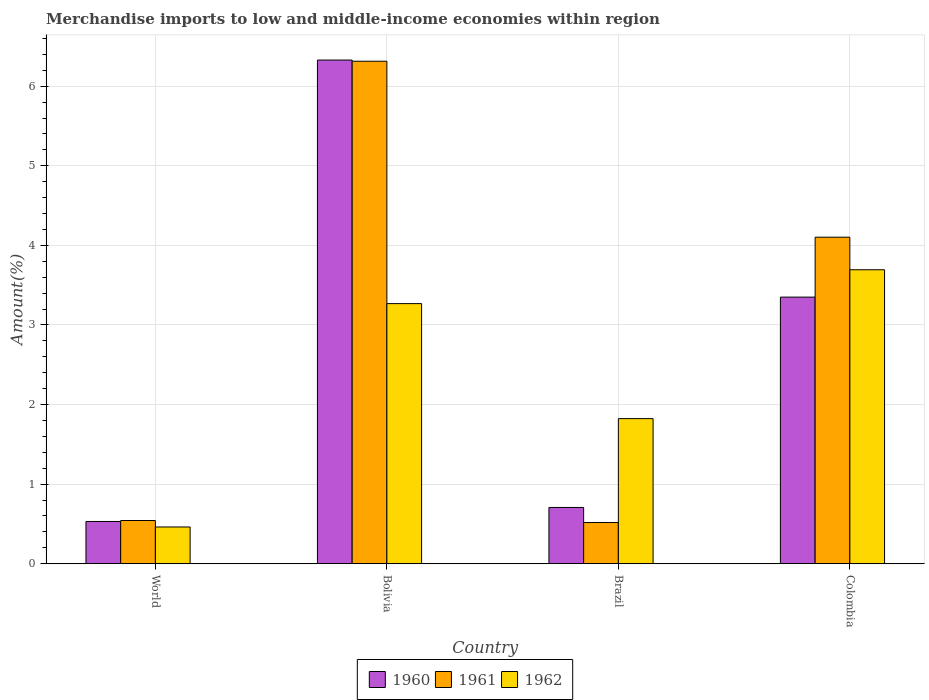How many groups of bars are there?
Keep it short and to the point. 4. Are the number of bars per tick equal to the number of legend labels?
Make the answer very short. Yes. Are the number of bars on each tick of the X-axis equal?
Provide a short and direct response. Yes. How many bars are there on the 2nd tick from the right?
Offer a very short reply. 3. In how many cases, is the number of bars for a given country not equal to the number of legend labels?
Offer a very short reply. 0. What is the percentage of amount earned from merchandise imports in 1962 in Bolivia?
Your response must be concise. 3.27. Across all countries, what is the maximum percentage of amount earned from merchandise imports in 1961?
Give a very brief answer. 6.31. Across all countries, what is the minimum percentage of amount earned from merchandise imports in 1962?
Give a very brief answer. 0.46. In which country was the percentage of amount earned from merchandise imports in 1961 maximum?
Your response must be concise. Bolivia. What is the total percentage of amount earned from merchandise imports in 1961 in the graph?
Keep it short and to the point. 11.48. What is the difference between the percentage of amount earned from merchandise imports in 1962 in Colombia and that in World?
Your answer should be compact. 3.23. What is the difference between the percentage of amount earned from merchandise imports in 1960 in Brazil and the percentage of amount earned from merchandise imports in 1962 in Bolivia?
Make the answer very short. -2.56. What is the average percentage of amount earned from merchandise imports in 1962 per country?
Provide a short and direct response. 2.31. What is the difference between the percentage of amount earned from merchandise imports of/in 1962 and percentage of amount earned from merchandise imports of/in 1960 in Brazil?
Offer a very short reply. 1.12. In how many countries, is the percentage of amount earned from merchandise imports in 1960 greater than 0.4 %?
Keep it short and to the point. 4. What is the ratio of the percentage of amount earned from merchandise imports in 1962 in Bolivia to that in Colombia?
Your response must be concise. 0.88. Is the percentage of amount earned from merchandise imports in 1962 in Bolivia less than that in World?
Make the answer very short. No. Is the difference between the percentage of amount earned from merchandise imports in 1962 in Bolivia and Colombia greater than the difference between the percentage of amount earned from merchandise imports in 1960 in Bolivia and Colombia?
Your answer should be compact. No. What is the difference between the highest and the second highest percentage of amount earned from merchandise imports in 1960?
Your answer should be very brief. -2.64. What is the difference between the highest and the lowest percentage of amount earned from merchandise imports in 1961?
Ensure brevity in your answer.  5.8. In how many countries, is the percentage of amount earned from merchandise imports in 1960 greater than the average percentage of amount earned from merchandise imports in 1960 taken over all countries?
Keep it short and to the point. 2. Is the sum of the percentage of amount earned from merchandise imports in 1960 in Bolivia and World greater than the maximum percentage of amount earned from merchandise imports in 1962 across all countries?
Your answer should be compact. Yes. What does the 1st bar from the right in Bolivia represents?
Your answer should be compact. 1962. What is the difference between two consecutive major ticks on the Y-axis?
Give a very brief answer. 1. Does the graph contain any zero values?
Offer a terse response. No. Does the graph contain grids?
Provide a succinct answer. Yes. Where does the legend appear in the graph?
Offer a terse response. Bottom center. How are the legend labels stacked?
Provide a short and direct response. Horizontal. What is the title of the graph?
Your answer should be very brief. Merchandise imports to low and middle-income economies within region. Does "1998" appear as one of the legend labels in the graph?
Offer a terse response. No. What is the label or title of the Y-axis?
Your answer should be very brief. Amount(%). What is the Amount(%) of 1960 in World?
Give a very brief answer. 0.53. What is the Amount(%) in 1961 in World?
Keep it short and to the point. 0.54. What is the Amount(%) of 1962 in World?
Provide a short and direct response. 0.46. What is the Amount(%) in 1960 in Bolivia?
Offer a very short reply. 6.33. What is the Amount(%) in 1961 in Bolivia?
Offer a very short reply. 6.31. What is the Amount(%) of 1962 in Bolivia?
Give a very brief answer. 3.27. What is the Amount(%) in 1960 in Brazil?
Your response must be concise. 0.71. What is the Amount(%) in 1961 in Brazil?
Offer a very short reply. 0.52. What is the Amount(%) in 1962 in Brazil?
Ensure brevity in your answer.  1.82. What is the Amount(%) of 1960 in Colombia?
Provide a short and direct response. 3.35. What is the Amount(%) in 1961 in Colombia?
Provide a short and direct response. 4.1. What is the Amount(%) of 1962 in Colombia?
Offer a terse response. 3.69. Across all countries, what is the maximum Amount(%) of 1960?
Offer a very short reply. 6.33. Across all countries, what is the maximum Amount(%) of 1961?
Offer a terse response. 6.31. Across all countries, what is the maximum Amount(%) in 1962?
Ensure brevity in your answer.  3.69. Across all countries, what is the minimum Amount(%) of 1960?
Your response must be concise. 0.53. Across all countries, what is the minimum Amount(%) of 1961?
Provide a succinct answer. 0.52. Across all countries, what is the minimum Amount(%) of 1962?
Give a very brief answer. 0.46. What is the total Amount(%) in 1960 in the graph?
Make the answer very short. 10.92. What is the total Amount(%) in 1961 in the graph?
Your response must be concise. 11.48. What is the total Amount(%) in 1962 in the graph?
Your answer should be very brief. 9.25. What is the difference between the Amount(%) in 1960 in World and that in Bolivia?
Provide a succinct answer. -5.8. What is the difference between the Amount(%) in 1961 in World and that in Bolivia?
Offer a very short reply. -5.77. What is the difference between the Amount(%) of 1962 in World and that in Bolivia?
Your response must be concise. -2.81. What is the difference between the Amount(%) of 1960 in World and that in Brazil?
Ensure brevity in your answer.  -0.18. What is the difference between the Amount(%) of 1961 in World and that in Brazil?
Offer a terse response. 0.03. What is the difference between the Amount(%) in 1962 in World and that in Brazil?
Give a very brief answer. -1.36. What is the difference between the Amount(%) in 1960 in World and that in Colombia?
Your response must be concise. -2.82. What is the difference between the Amount(%) in 1961 in World and that in Colombia?
Make the answer very short. -3.56. What is the difference between the Amount(%) in 1962 in World and that in Colombia?
Give a very brief answer. -3.23. What is the difference between the Amount(%) of 1960 in Bolivia and that in Brazil?
Your answer should be very brief. 5.62. What is the difference between the Amount(%) in 1961 in Bolivia and that in Brazil?
Offer a very short reply. 5.8. What is the difference between the Amount(%) of 1962 in Bolivia and that in Brazil?
Make the answer very short. 1.45. What is the difference between the Amount(%) in 1960 in Bolivia and that in Colombia?
Your answer should be compact. 2.98. What is the difference between the Amount(%) in 1961 in Bolivia and that in Colombia?
Provide a succinct answer. 2.21. What is the difference between the Amount(%) in 1962 in Bolivia and that in Colombia?
Your response must be concise. -0.43. What is the difference between the Amount(%) in 1960 in Brazil and that in Colombia?
Keep it short and to the point. -2.64. What is the difference between the Amount(%) in 1961 in Brazil and that in Colombia?
Give a very brief answer. -3.59. What is the difference between the Amount(%) of 1962 in Brazil and that in Colombia?
Offer a very short reply. -1.87. What is the difference between the Amount(%) of 1960 in World and the Amount(%) of 1961 in Bolivia?
Your answer should be compact. -5.78. What is the difference between the Amount(%) in 1960 in World and the Amount(%) in 1962 in Bolivia?
Offer a terse response. -2.74. What is the difference between the Amount(%) of 1961 in World and the Amount(%) of 1962 in Bolivia?
Provide a short and direct response. -2.73. What is the difference between the Amount(%) in 1960 in World and the Amount(%) in 1961 in Brazil?
Provide a succinct answer. 0.01. What is the difference between the Amount(%) of 1960 in World and the Amount(%) of 1962 in Brazil?
Ensure brevity in your answer.  -1.29. What is the difference between the Amount(%) in 1961 in World and the Amount(%) in 1962 in Brazil?
Give a very brief answer. -1.28. What is the difference between the Amount(%) of 1960 in World and the Amount(%) of 1961 in Colombia?
Ensure brevity in your answer.  -3.57. What is the difference between the Amount(%) of 1960 in World and the Amount(%) of 1962 in Colombia?
Make the answer very short. -3.16. What is the difference between the Amount(%) in 1961 in World and the Amount(%) in 1962 in Colombia?
Your answer should be very brief. -3.15. What is the difference between the Amount(%) of 1960 in Bolivia and the Amount(%) of 1961 in Brazil?
Offer a terse response. 5.81. What is the difference between the Amount(%) in 1960 in Bolivia and the Amount(%) in 1962 in Brazil?
Your answer should be very brief. 4.51. What is the difference between the Amount(%) of 1961 in Bolivia and the Amount(%) of 1962 in Brazil?
Your answer should be compact. 4.49. What is the difference between the Amount(%) in 1960 in Bolivia and the Amount(%) in 1961 in Colombia?
Your answer should be very brief. 2.23. What is the difference between the Amount(%) in 1960 in Bolivia and the Amount(%) in 1962 in Colombia?
Offer a very short reply. 2.64. What is the difference between the Amount(%) in 1961 in Bolivia and the Amount(%) in 1962 in Colombia?
Your response must be concise. 2.62. What is the difference between the Amount(%) in 1960 in Brazil and the Amount(%) in 1961 in Colombia?
Provide a short and direct response. -3.4. What is the difference between the Amount(%) in 1960 in Brazil and the Amount(%) in 1962 in Colombia?
Your answer should be very brief. -2.99. What is the difference between the Amount(%) in 1961 in Brazil and the Amount(%) in 1962 in Colombia?
Offer a terse response. -3.18. What is the average Amount(%) in 1960 per country?
Provide a succinct answer. 2.73. What is the average Amount(%) of 1961 per country?
Offer a very short reply. 2.87. What is the average Amount(%) of 1962 per country?
Your answer should be compact. 2.31. What is the difference between the Amount(%) of 1960 and Amount(%) of 1961 in World?
Provide a succinct answer. -0.01. What is the difference between the Amount(%) in 1960 and Amount(%) in 1962 in World?
Your response must be concise. 0.07. What is the difference between the Amount(%) in 1961 and Amount(%) in 1962 in World?
Give a very brief answer. 0.08. What is the difference between the Amount(%) of 1960 and Amount(%) of 1961 in Bolivia?
Offer a very short reply. 0.01. What is the difference between the Amount(%) in 1960 and Amount(%) in 1962 in Bolivia?
Your answer should be very brief. 3.06. What is the difference between the Amount(%) of 1961 and Amount(%) of 1962 in Bolivia?
Provide a succinct answer. 3.05. What is the difference between the Amount(%) in 1960 and Amount(%) in 1961 in Brazil?
Offer a very short reply. 0.19. What is the difference between the Amount(%) in 1960 and Amount(%) in 1962 in Brazil?
Ensure brevity in your answer.  -1.12. What is the difference between the Amount(%) in 1961 and Amount(%) in 1962 in Brazil?
Your answer should be very brief. -1.31. What is the difference between the Amount(%) of 1960 and Amount(%) of 1961 in Colombia?
Your answer should be very brief. -0.75. What is the difference between the Amount(%) of 1960 and Amount(%) of 1962 in Colombia?
Give a very brief answer. -0.34. What is the difference between the Amount(%) in 1961 and Amount(%) in 1962 in Colombia?
Keep it short and to the point. 0.41. What is the ratio of the Amount(%) of 1960 in World to that in Bolivia?
Make the answer very short. 0.08. What is the ratio of the Amount(%) of 1961 in World to that in Bolivia?
Offer a terse response. 0.09. What is the ratio of the Amount(%) of 1962 in World to that in Bolivia?
Give a very brief answer. 0.14. What is the ratio of the Amount(%) of 1960 in World to that in Brazil?
Give a very brief answer. 0.75. What is the ratio of the Amount(%) of 1961 in World to that in Brazil?
Ensure brevity in your answer.  1.05. What is the ratio of the Amount(%) in 1962 in World to that in Brazil?
Offer a terse response. 0.25. What is the ratio of the Amount(%) of 1960 in World to that in Colombia?
Keep it short and to the point. 0.16. What is the ratio of the Amount(%) of 1961 in World to that in Colombia?
Ensure brevity in your answer.  0.13. What is the ratio of the Amount(%) of 1962 in World to that in Colombia?
Provide a succinct answer. 0.12. What is the ratio of the Amount(%) in 1960 in Bolivia to that in Brazil?
Offer a terse response. 8.95. What is the ratio of the Amount(%) in 1961 in Bolivia to that in Brazil?
Your answer should be compact. 12.2. What is the ratio of the Amount(%) of 1962 in Bolivia to that in Brazil?
Give a very brief answer. 1.79. What is the ratio of the Amount(%) of 1960 in Bolivia to that in Colombia?
Ensure brevity in your answer.  1.89. What is the ratio of the Amount(%) of 1961 in Bolivia to that in Colombia?
Ensure brevity in your answer.  1.54. What is the ratio of the Amount(%) of 1962 in Bolivia to that in Colombia?
Offer a very short reply. 0.88. What is the ratio of the Amount(%) of 1960 in Brazil to that in Colombia?
Provide a short and direct response. 0.21. What is the ratio of the Amount(%) in 1961 in Brazil to that in Colombia?
Make the answer very short. 0.13. What is the ratio of the Amount(%) of 1962 in Brazil to that in Colombia?
Ensure brevity in your answer.  0.49. What is the difference between the highest and the second highest Amount(%) in 1960?
Keep it short and to the point. 2.98. What is the difference between the highest and the second highest Amount(%) of 1961?
Make the answer very short. 2.21. What is the difference between the highest and the second highest Amount(%) in 1962?
Your answer should be very brief. 0.43. What is the difference between the highest and the lowest Amount(%) of 1960?
Make the answer very short. 5.8. What is the difference between the highest and the lowest Amount(%) in 1961?
Your response must be concise. 5.8. What is the difference between the highest and the lowest Amount(%) in 1962?
Your response must be concise. 3.23. 